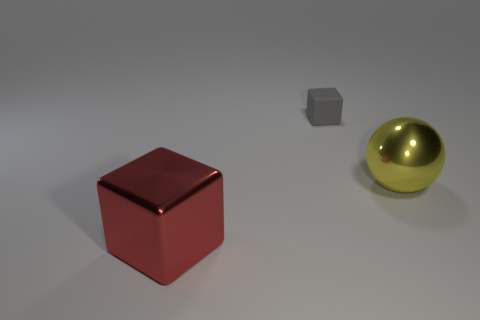Do the small gray matte thing and the big red metal thing have the same shape?
Provide a succinct answer. Yes. How many other objects are there of the same material as the tiny thing?
Provide a succinct answer. 0. What number of big objects are yellow metallic spheres or gray objects?
Provide a short and direct response. 1. Are there an equal number of large red blocks left of the large red thing and red things?
Make the answer very short. No. There is a shiny thing that is in front of the yellow thing; is there a tiny gray block that is left of it?
Your answer should be very brief. No. What number of other things are there of the same color as the matte thing?
Provide a short and direct response. 0. The large metallic ball is what color?
Keep it short and to the point. Yellow. There is a object that is both in front of the small gray matte block and to the left of the yellow ball; what is its size?
Your answer should be compact. Large. What number of things are either rubber objects behind the big cube or objects?
Keep it short and to the point. 3. There is a big thing that is the same material as the red block; what shape is it?
Your response must be concise. Sphere. 